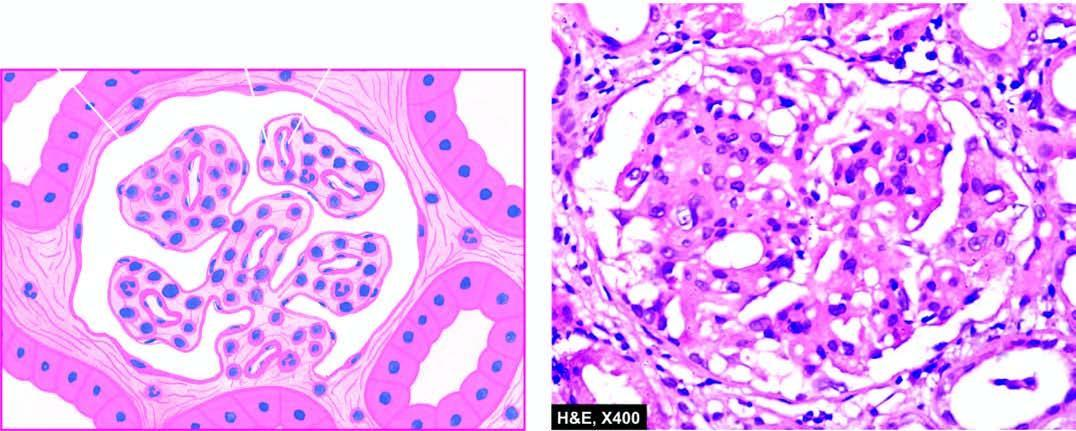what show lobulation and mesangial hypercellularity?
Answer the question using a single word or phrase. Glomerular tufts 